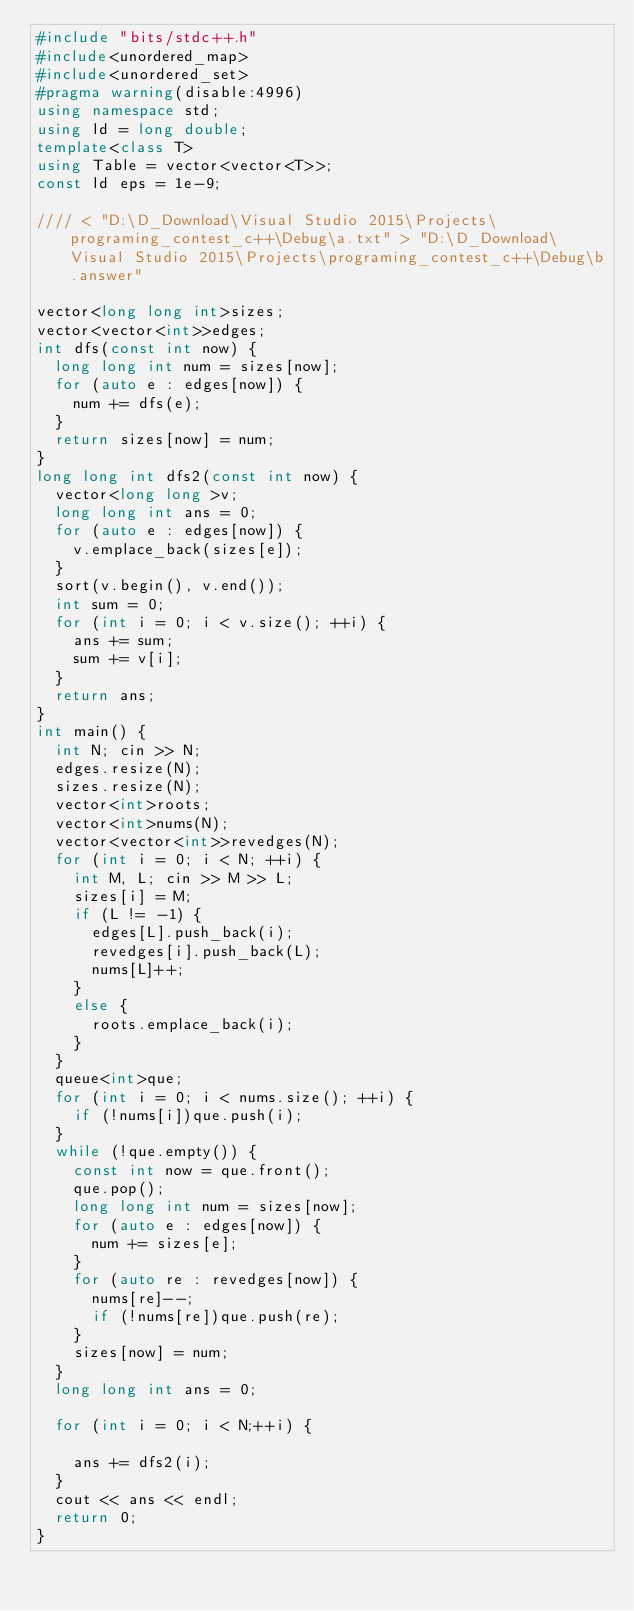<code> <loc_0><loc_0><loc_500><loc_500><_C++_>#include "bits/stdc++.h"
#include<unordered_map>
#include<unordered_set>
#pragma warning(disable:4996)
using namespace std;
using ld = long double;
template<class T>
using Table = vector<vector<T>>;
const ld eps = 1e-9;

//// < "D:\D_Download\Visual Studio 2015\Projects\programing_contest_c++\Debug\a.txt" > "D:\D_Download\Visual Studio 2015\Projects\programing_contest_c++\Debug\b.answer"

vector<long long int>sizes;
vector<vector<int>>edges;
int dfs(const int now) {
	long long int num = sizes[now];
	for (auto e : edges[now]) {
		num += dfs(e);
	}
	return sizes[now] = num;
}
long long int dfs2(const int now) {
	vector<long long >v;
	long long int ans = 0;
	for (auto e : edges[now]) {
		v.emplace_back(sizes[e]);
	}
	sort(v.begin(), v.end());
	int sum = 0;
	for (int i = 0; i < v.size(); ++i) {
		ans += sum;
		sum += v[i];
	}
	return ans;
}
int main() {
	int N; cin >> N;
	edges.resize(N);
	sizes.resize(N);
	vector<int>roots;
	vector<int>nums(N);
	vector<vector<int>>revedges(N);
	for (int i = 0; i < N; ++i) {
		int M, L; cin >> M >> L;
		sizes[i] = M;
		if (L != -1) {
			edges[L].push_back(i);
			revedges[i].push_back(L);
			nums[L]++;
		}
		else {
			roots.emplace_back(i);
		}
	}
	queue<int>que;
	for (int i = 0; i < nums.size(); ++i) {
		if (!nums[i])que.push(i);
	}
	while (!que.empty()) {
		const int now = que.front();
		que.pop();
		long long int num = sizes[now];
		for (auto e : edges[now]) {
			num += sizes[e];
		}
		for (auto re : revedges[now]) {
			nums[re]--;
			if (!nums[re])que.push(re);
		}
		sizes[now] = num;
	}
	long long int ans = 0;
	
	for (int i = 0; i < N;++i) {

		ans += dfs2(i);
	}
	cout << ans << endl;
	return 0;
}</code> 